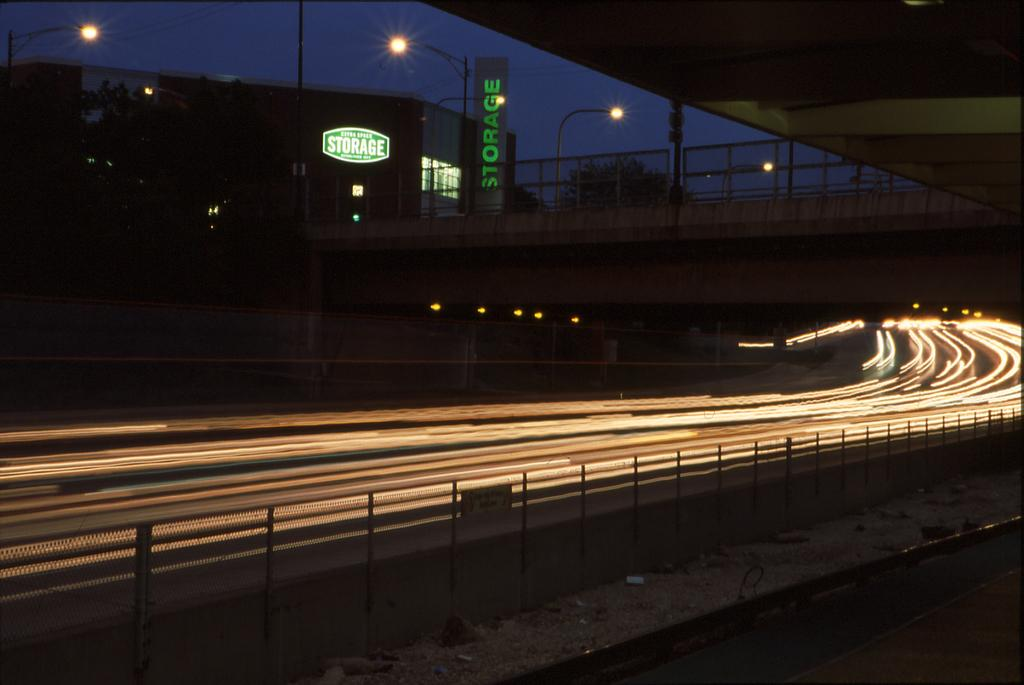What type of structures can be seen in the image? There are buildings in the image. What other natural elements are present in the image? There are trees in the image. What is happening on the road in the image? Vehicles are present on the road in the image. What type of barrier is visible in the image? There is fencing in the image. What type of infrastructure is visible in the image? A flyover is visible in the image. What type of traffic control is present in the image? Traffic signals are present in the image. What type of illumination is visible in the image? Lights are visible in the image. What part of the natural environment is visible in the image? The sky is visible in the image. What type of grain is being harvested in the image? There is no grain present in the image; it features buildings, trees, vehicles, fencing, a flyover, traffic signals, lights, and the sky. How many bubbles can be seen floating in the image? There are no bubbles present in the image. 